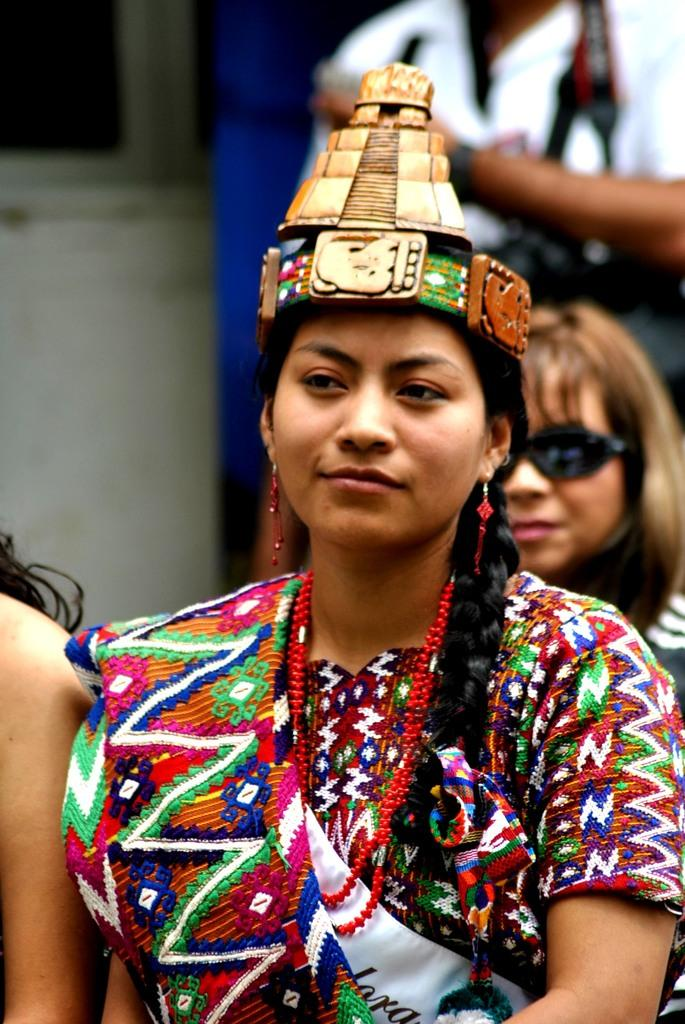How many people are in the image? There are people in the image, but the exact number is not specified. What is the lady wearing on her head? A lady is wearing an object on her head. What is the person at the top right corner of the image doing? There is a person holding objects at the top right corner of the image. What type of dinner is being served in the image? There is no dinner present in the image. Can you describe the woman's outfit in the image? The facts provided do not mention a woman or her outfit, only a lady wearing an object on her head. 